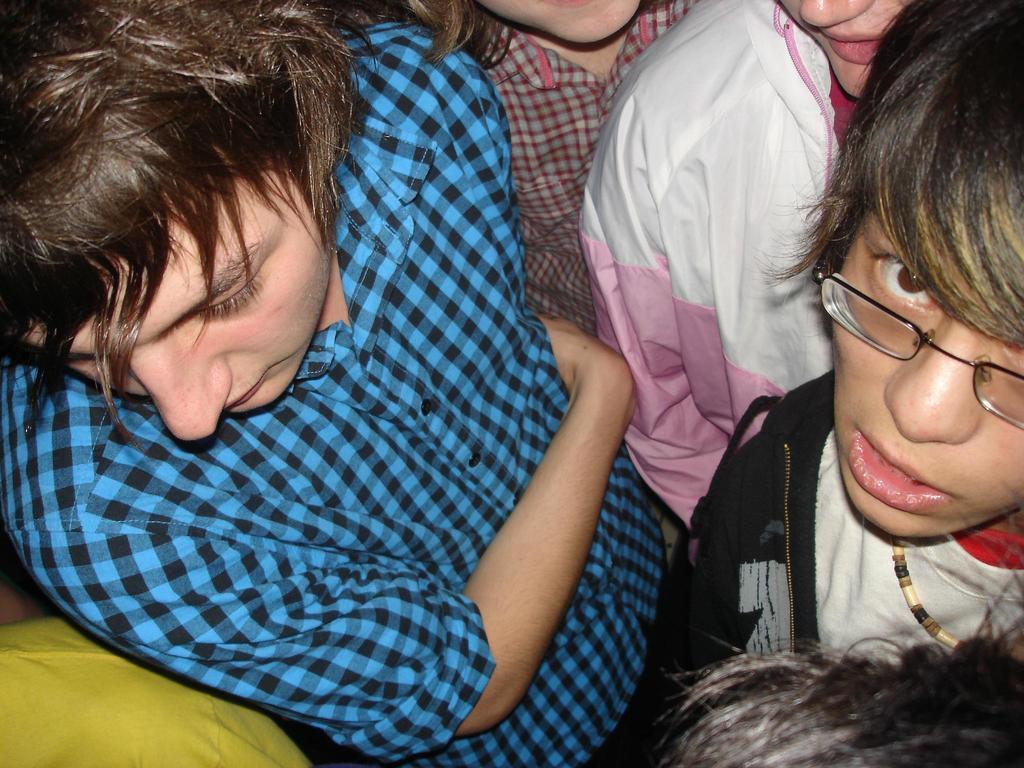Describe this image in one or two sentences. There are many people. On the left side there is a person wearing a blue and black check shirt. On the right side a person is wearing black jacket and specs. Near to that a person is wearing a white and pink jacket. 